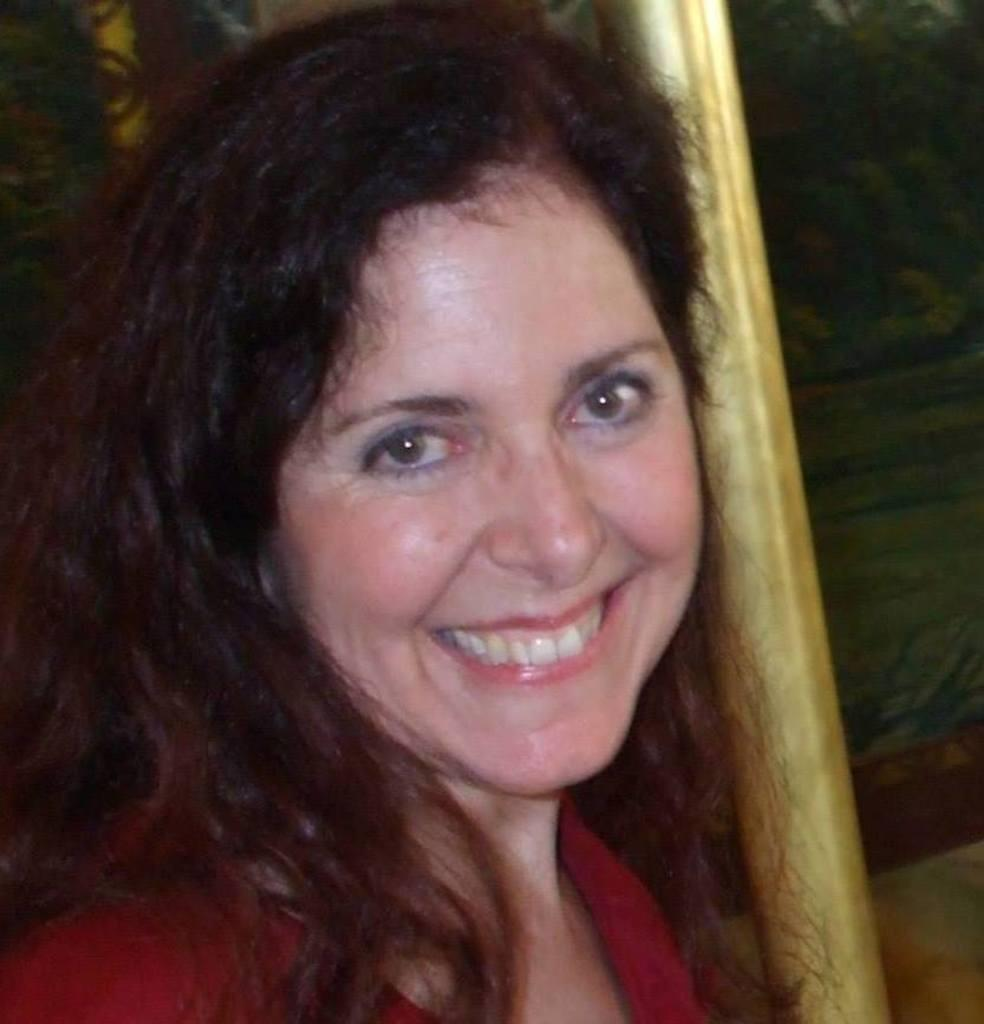Who is present in the image? There is a woman in the image. What is the woman doing in the image? The woman is smiling in the image. What is the woman wearing in the image? The woman is wearing a red top in the image. What can be seen on the right side of the image? There is a pole on the right side of the image. What is visible in the background of the image? There appears to be a wall in the background of the image. What type of connection can be seen between the woman and the rifle in the image? There is no rifle present in the image, so there is no connection between the woman and a rifle. 